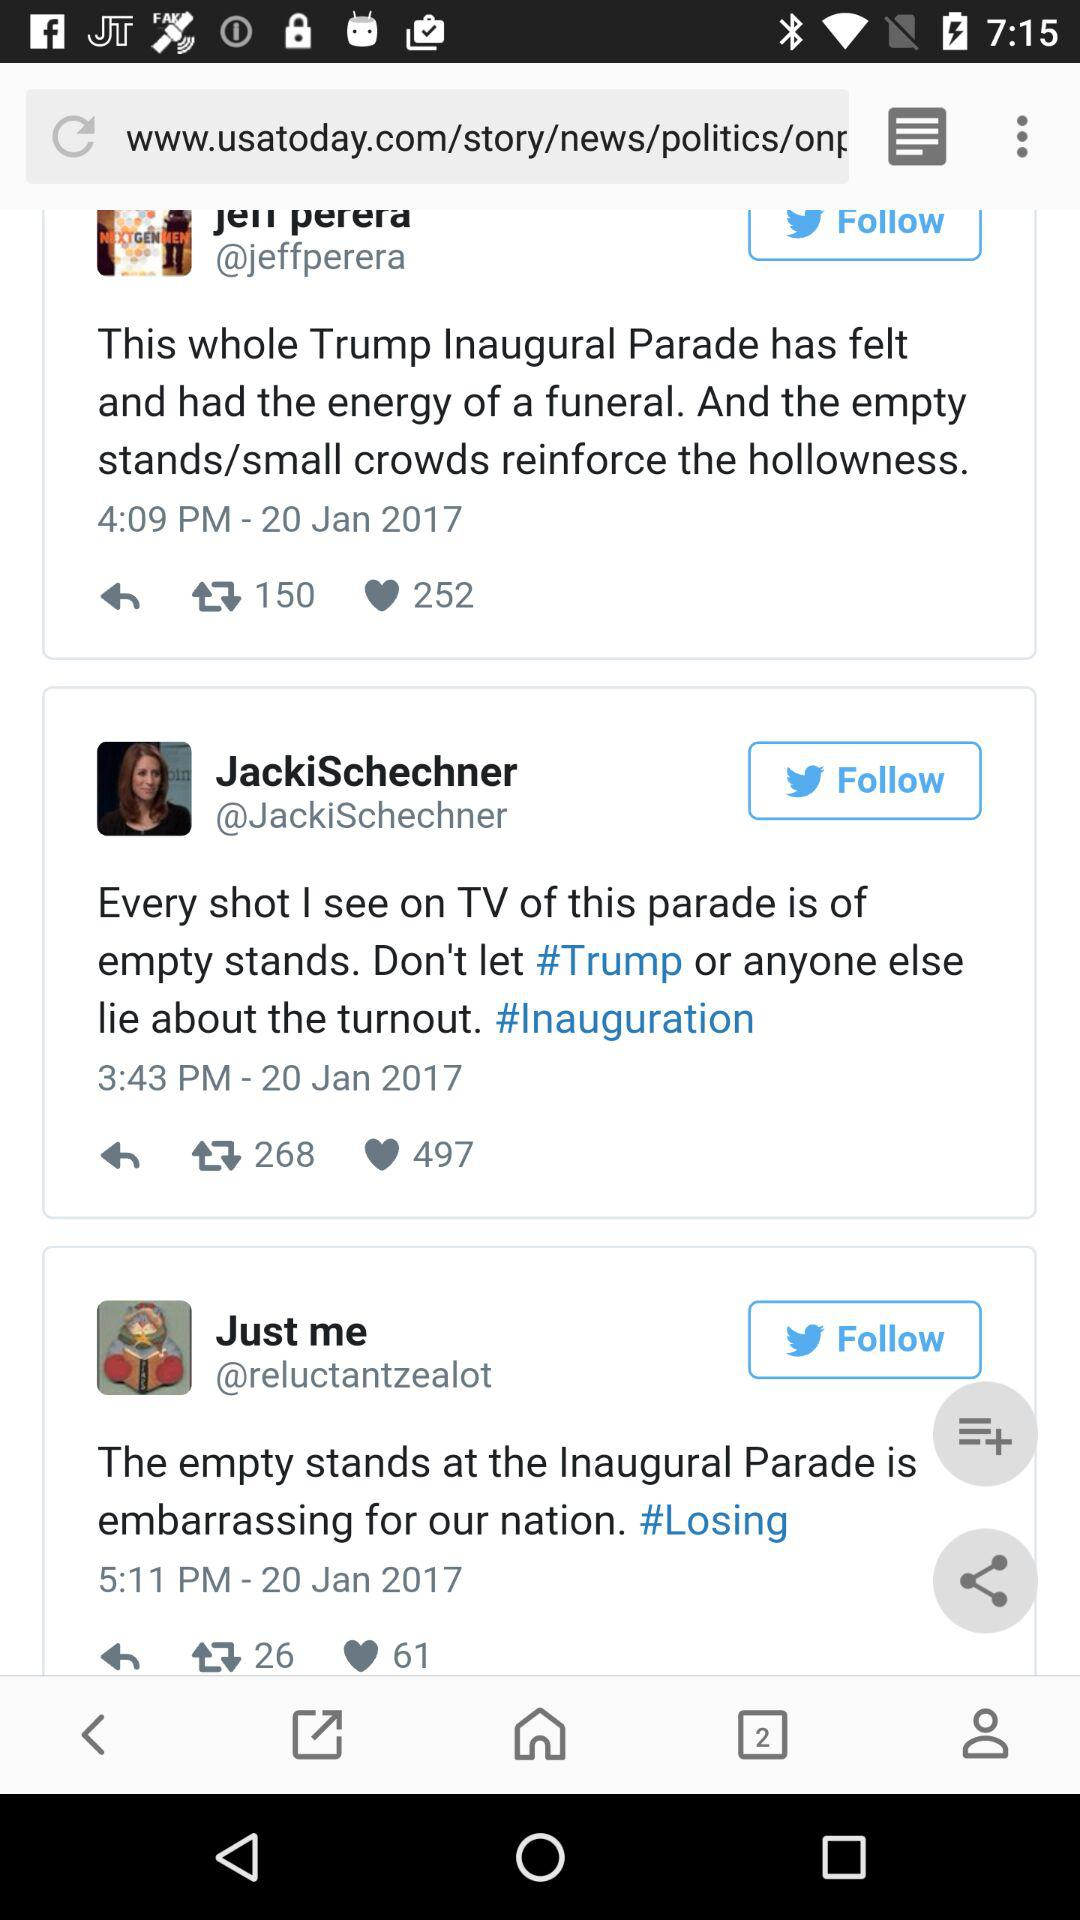What time was the post posted by "Just me"? The post was posted at 5:11 p.m. by "Just me". 